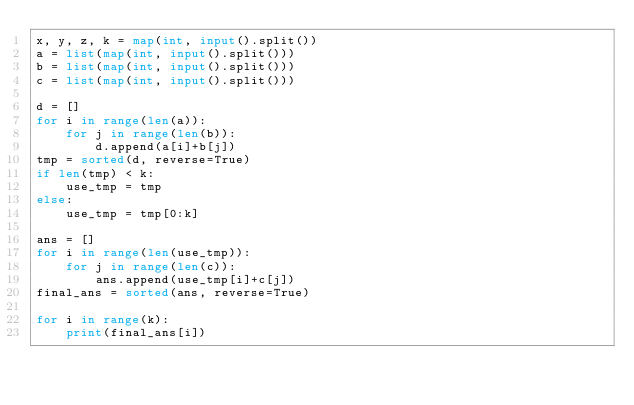<code> <loc_0><loc_0><loc_500><loc_500><_Python_>x, y, z, k = map(int, input().split())
a = list(map(int, input().split()))
b = list(map(int, input().split()))
c = list(map(int, input().split()))

d = []
for i in range(len(a)):
    for j in range(len(b)):
        d.append(a[i]+b[j])
tmp = sorted(d, reverse=True)
if len(tmp) < k:
    use_tmp = tmp
else:
    use_tmp = tmp[0:k]
    
ans = []
for i in range(len(use_tmp)):
    for j in range(len(c)):
        ans.append(use_tmp[i]+c[j])
final_ans = sorted(ans, reverse=True)

for i in range(k):
    print(final_ans[i])</code> 